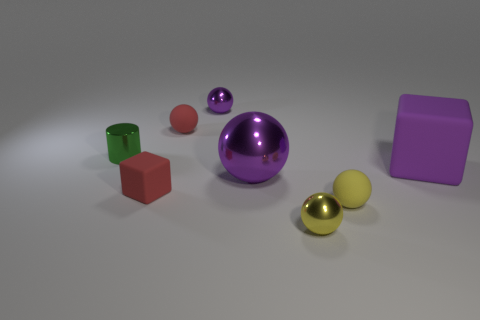There is a purple sphere in front of the tiny red ball; what is its size?
Provide a short and direct response. Large. What shape is the green object that is made of the same material as the tiny purple thing?
Provide a short and direct response. Cylinder. Are the small thing that is to the left of the tiny rubber cube and the large purple block made of the same material?
Give a very brief answer. No. What number of other things are made of the same material as the tiny green cylinder?
Offer a terse response. 3. What number of things are either purple matte things that are in front of the small green object or rubber things in front of the large purple metallic object?
Give a very brief answer. 3. Do the shiny object to the left of the tiny purple object and the shiny thing in front of the tiny red block have the same shape?
Provide a succinct answer. No. What is the shape of the purple shiny object that is the same size as the cylinder?
Offer a terse response. Sphere. What number of shiny things are either green objects or blocks?
Provide a short and direct response. 1. Do the red object in front of the tiny green cylinder and the tiny red thing that is behind the cylinder have the same material?
Your answer should be compact. Yes. What color is the big cube that is made of the same material as the tiny red ball?
Your answer should be very brief. Purple. 